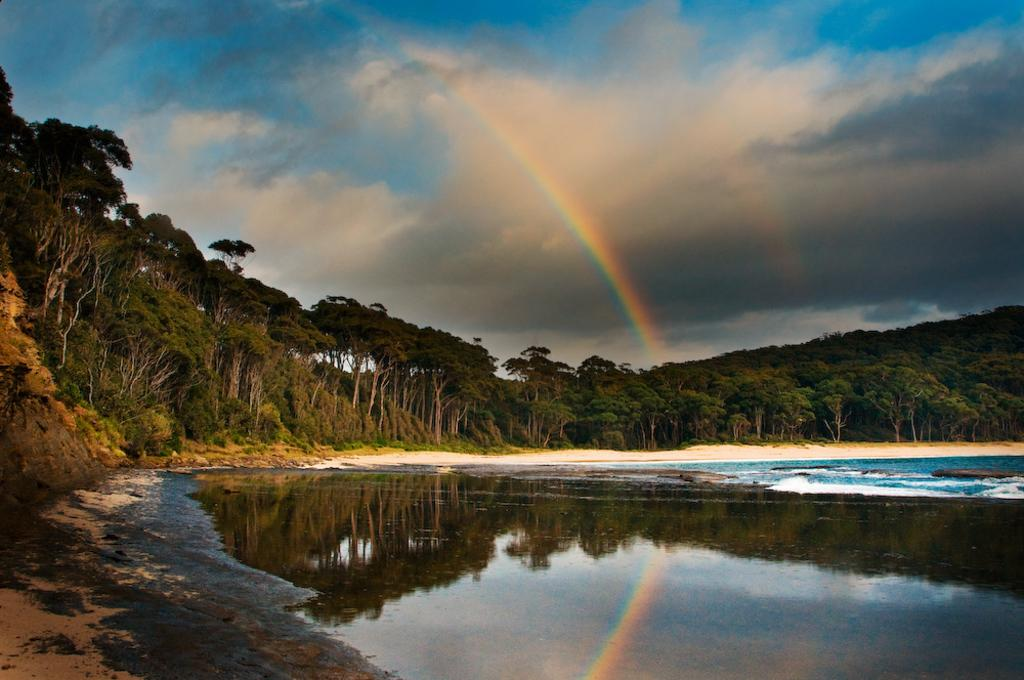What is one of the natural elements present in the image? There is water in the image. What type of vegetation can be seen in the image? There are trees in the image. What color is the sky in the image? The sky is blue in the image. What additional feature is visible in the sky? There is a rainbow visible in the image. What flavor of paper can be seen in the image? There is no paper present in the image, so it is not possible to determine its flavor. 